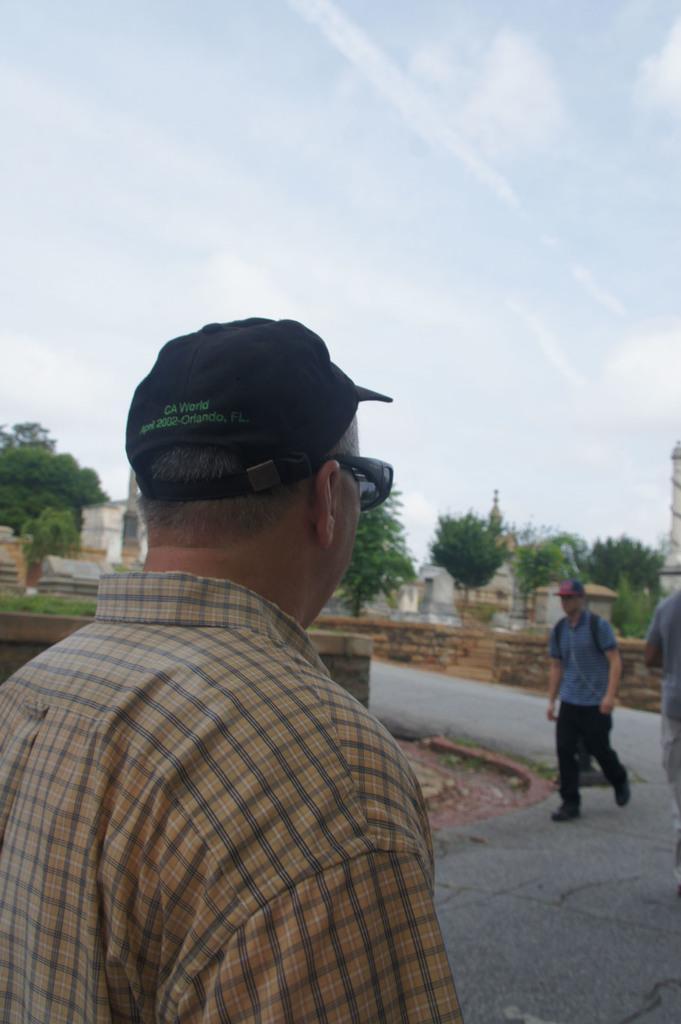Can you describe this image briefly? In the foreground of this image, there is a man. On the right, there are two people on the road. In the background, there are trees, few buildings and the sky. 